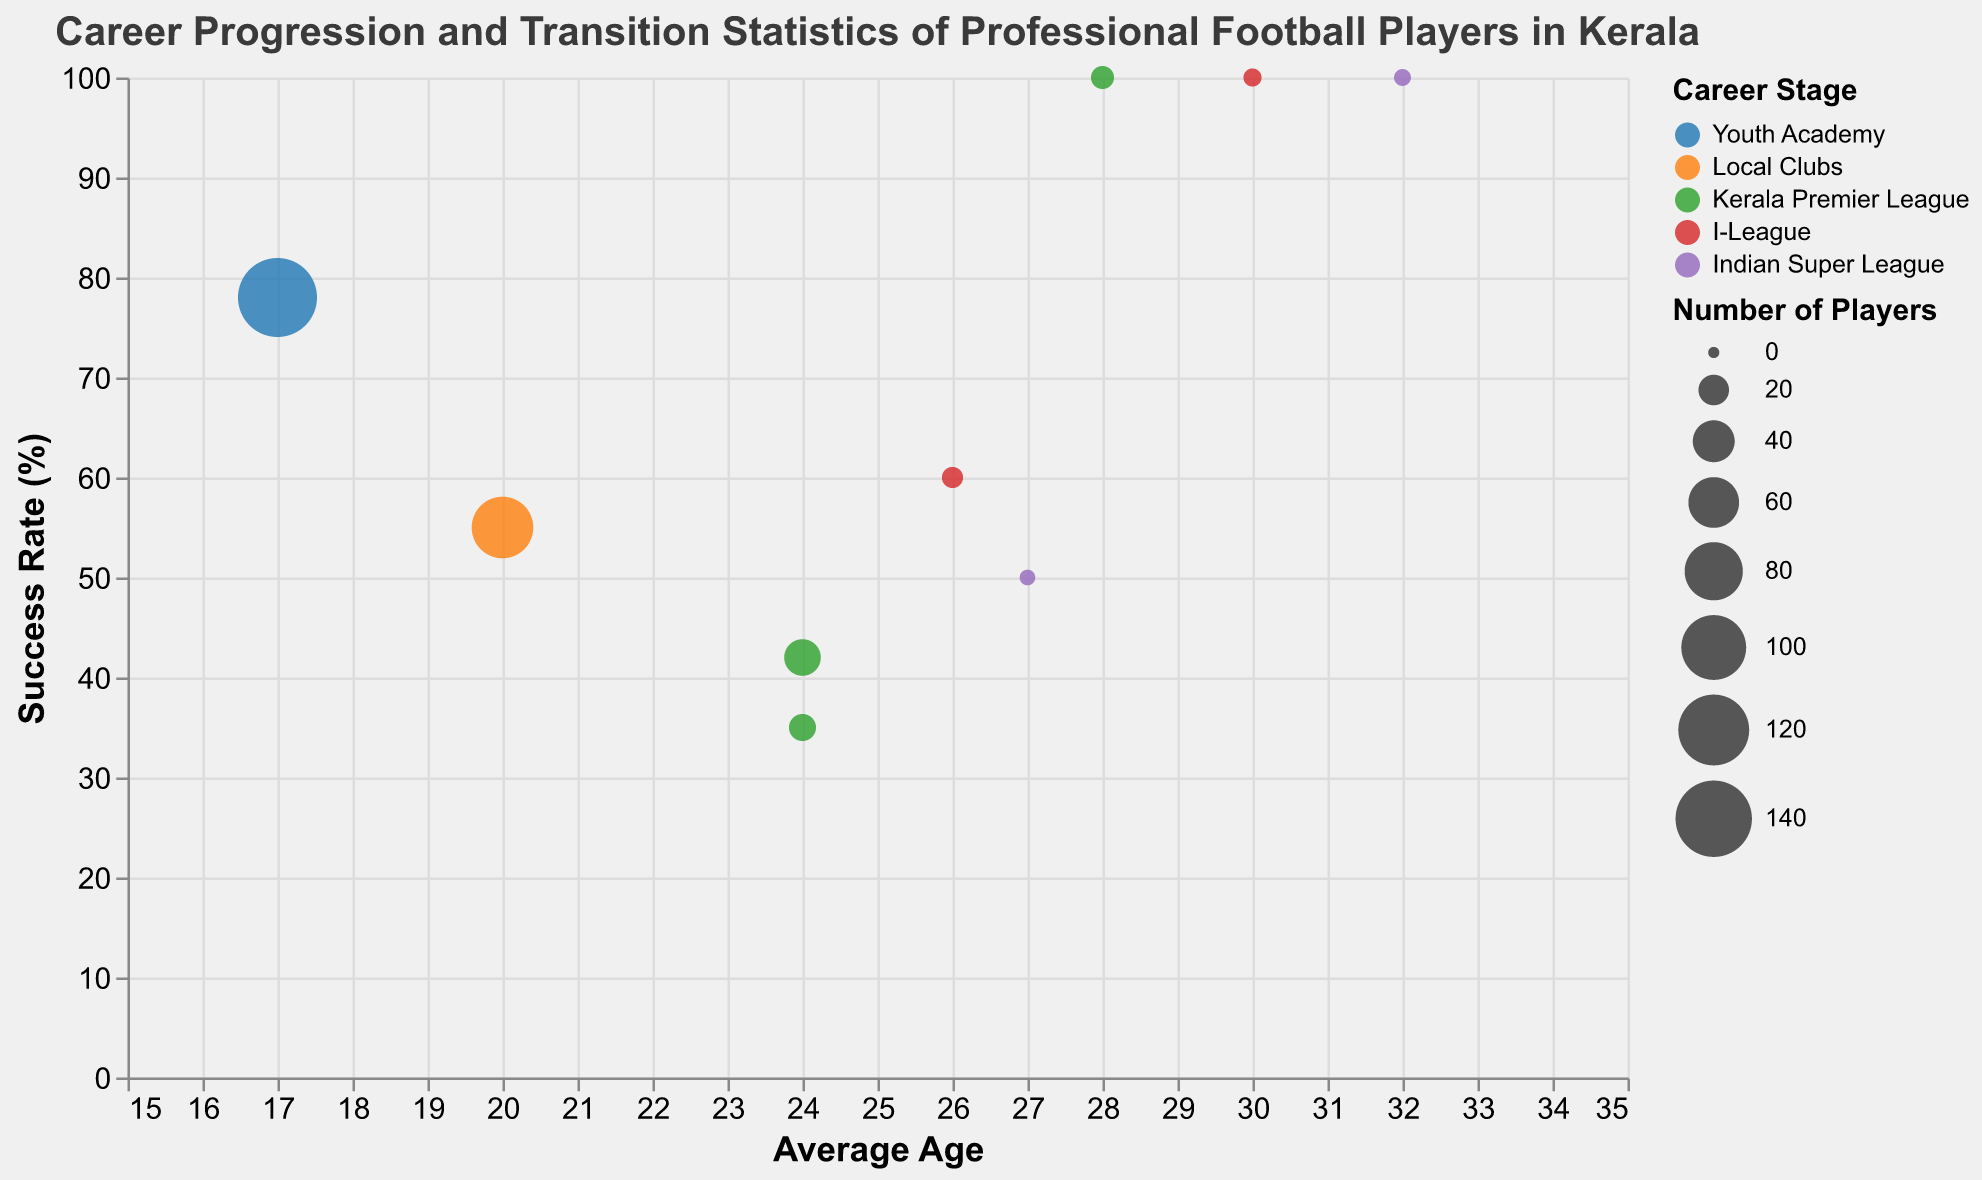How many career stages are represented in the chart? The color legend indicates different career stages. Counting the distinct colors, we see five career stages: "Youth Academy," "Local Clubs," "Kerala Premier League," "I-League," and "Indian Super League."
Answer: 5 Which transition type involves the highest number of players? Looking at the size of the bubbles, the largest bubble represents players transitioning from "Youth Academy" to "Local Clubs" with 150 players.
Answer: Youth Academy to Local Clubs What is the average age of players transitioning from the Kerala Premier League to the Indian Super League? Referring to the tooltip for the transition from "Kerala Premier League" to "Indian Super League," the average age is specified as 24.
Answer: 24 Which stage has the highest overall satisfaction for its transitions? Examining the tooltips, transitions from the "Indian Super League" to "Overseas Clubs" have the highest overall satisfaction score of 90.
Answer: Indian Super League to Overseas Clubs Compare the success rates of players transitioning from "Kerala Premier League" to the "I-League" and those going to the "Indian Super League." Which is higher? According to the tooltips, transitions from "Kerala Premier League" to "I-League" have a success rate of 42%, while those to the "Indian Super League" have a success rate of 35%.
Answer: Kerala Premier League to I-League What is the total number of players retiring from each career stage? Adding the number of players retiring from each stage: "Kerala Premier League" (10), "I-League" (5), and "Indian Super League" (4), we get 10+5+4=19 players.
Answer: 19 Which transition type from the Indian Super League involves the youngest average age? Comparing the different transition types from "Indian Super League," those transitioning to "Overseas Clubs" have an average age of 27, which is younger than those retiring with an average age of 32.
Answer: To Overseas Clubs What's the success rate for players transitioning from the I-League to the Indian Super League? By checking the tooltip, the success rate for this transition is indicated as 60%.
Answer: 60 What is the difference in overall satisfaction between transitions from the Kerala Premier League to Indian Super League and Kerala Premier League to I-League? Overall satisfaction from "Kerala Premier League" to "Indian Super League" is 80, while from "Kerala Premier League" to "I-League" is 70. The difference is 80-70=10.
Answer: 10 